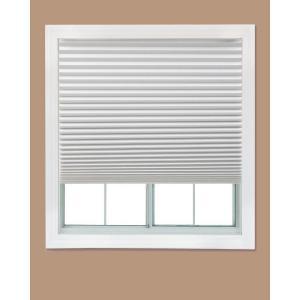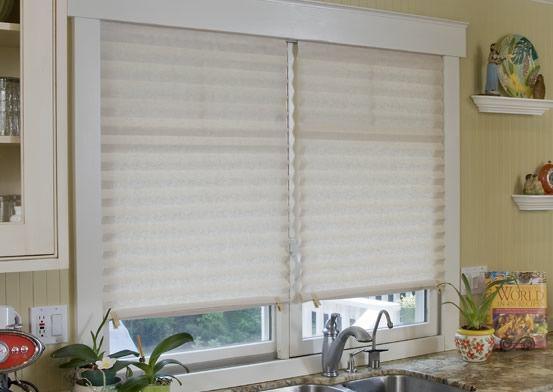The first image is the image on the left, the second image is the image on the right. Given the left and right images, does the statement "There are three blinds." hold true? Answer yes or no. Yes. 